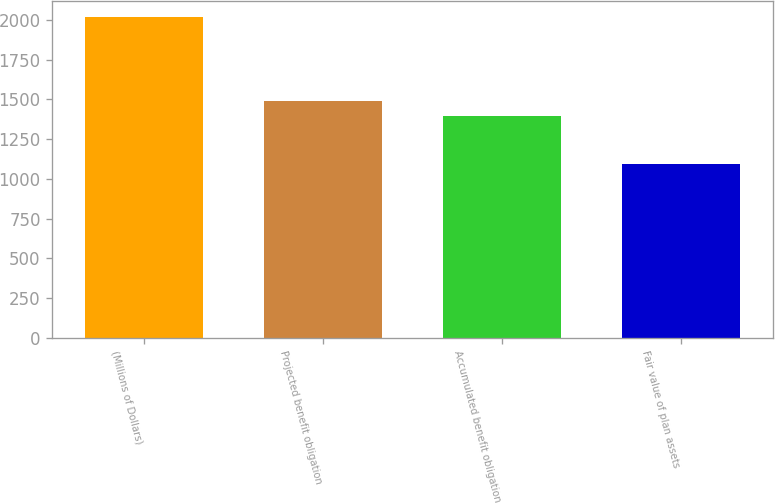Convert chart to OTSL. <chart><loc_0><loc_0><loc_500><loc_500><bar_chart><fcel>(Millions of Dollars)<fcel>Projected benefit obligation<fcel>Accumulated benefit obligation<fcel>Fair value of plan assets<nl><fcel>2017<fcel>1487.15<fcel>1395.1<fcel>1096.5<nl></chart> 